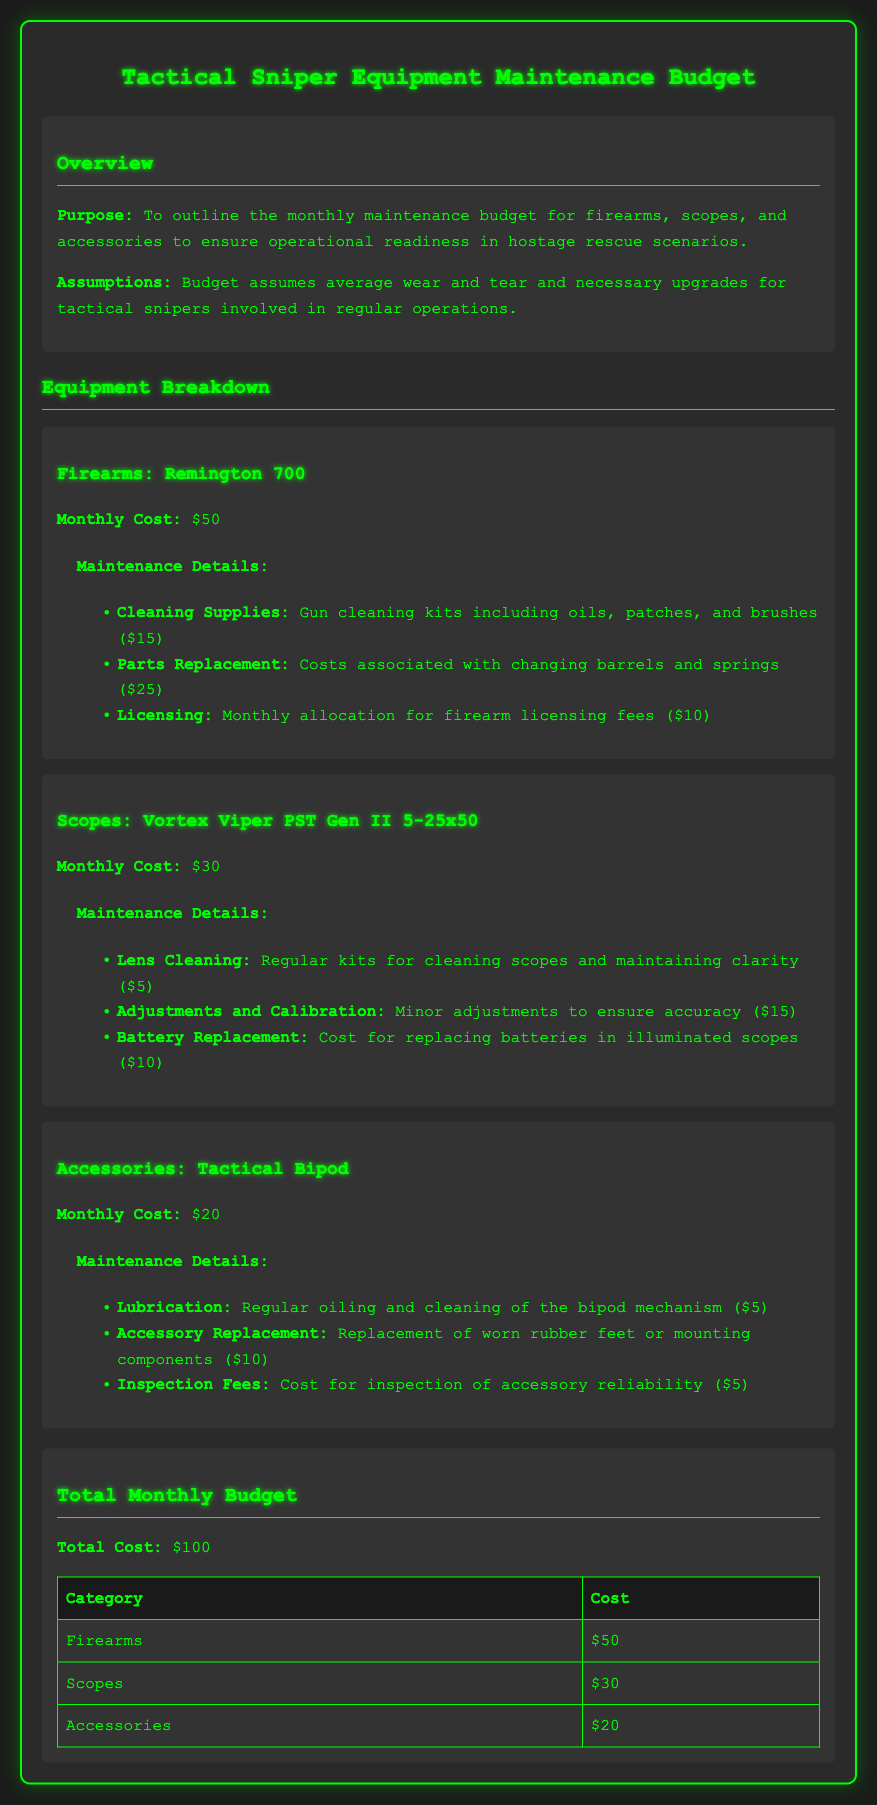What is the monthly cost for firearms? The monthly cost for firearms is mentioned under the firearms section, specifying that it is $50.
Answer: $50 What is included in the maintenance details for scopes? The maintenance details for scopes include lens cleaning, adjustments, and battery replacement, which are explicitly listed in the scope section.
Answer: Lens cleaning, adjustments, battery replacement How much is allocated for licensing fees monthly? The document states that there is a $10 allocation for firearm licensing fees included in the firearms maintenance costs.
Answer: $10 What is the total monthly budget for all equipment? The total monthly budget is calculated by adding the costs from firearms, scopes, and accessories, resulting in $100.
Answer: $100 What are the primary maintenance details for the tactical bipod? The maintenance details for the tactical bipod include lubrication, accessory replacement, and inspection fees, as detailed in its section.
Answer: Lubrication, accessory replacement, inspection fees How much does lens cleaning cost for scopes? The document specifies that lens cleaning for scopes costs $5 as part of the maintenance details.
Answer: $5 Which equipment has the highest monthly maintenance cost? By reviewing the maintenance costs listed, firearms have the highest cost at $50.
Answer: Firearms What are the total costs attributed to scopes? The total cost attributed to scopes, found in the document, is $30.
Answer: $30 